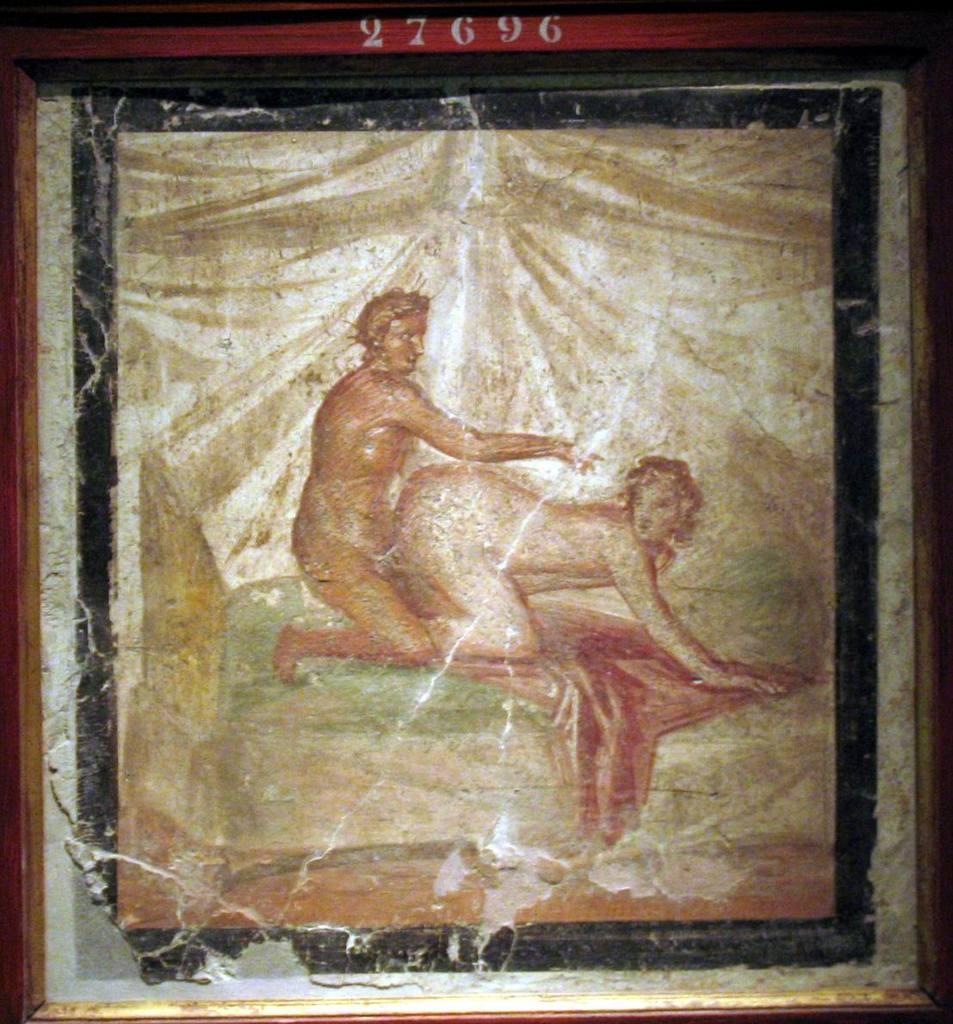Can you describe this image briefly? Here I can see a frame on which there is a painting of two persons. 